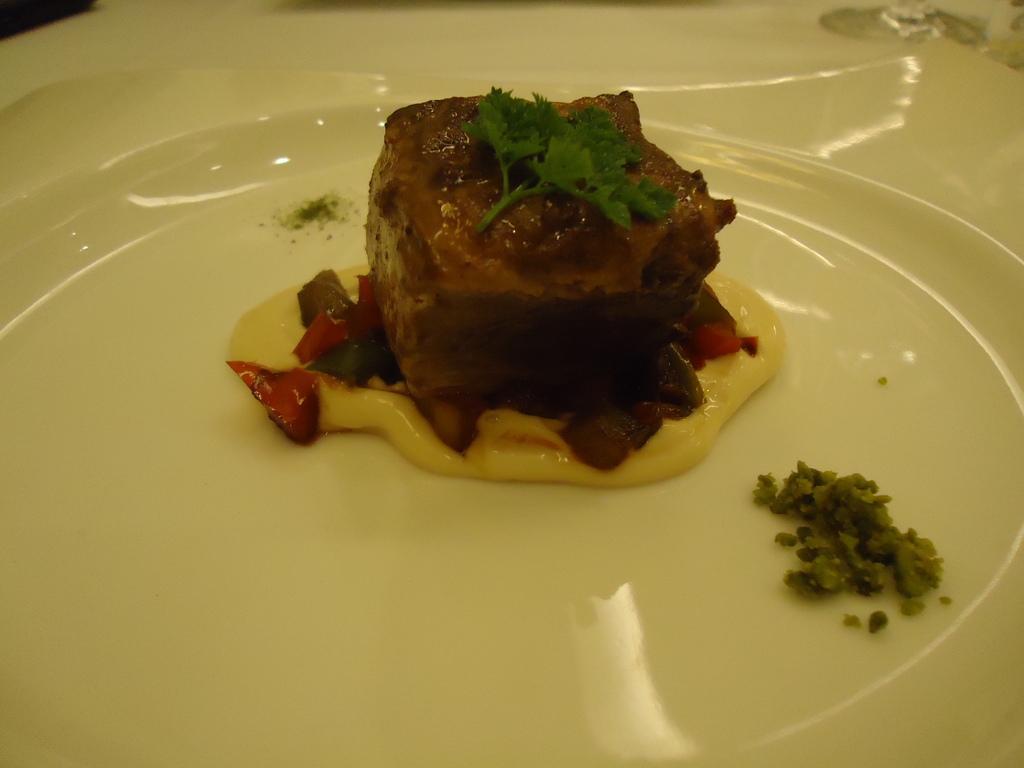In one or two sentences, can you explain what this image depicts? In this picture I can see a food item on the plate. 